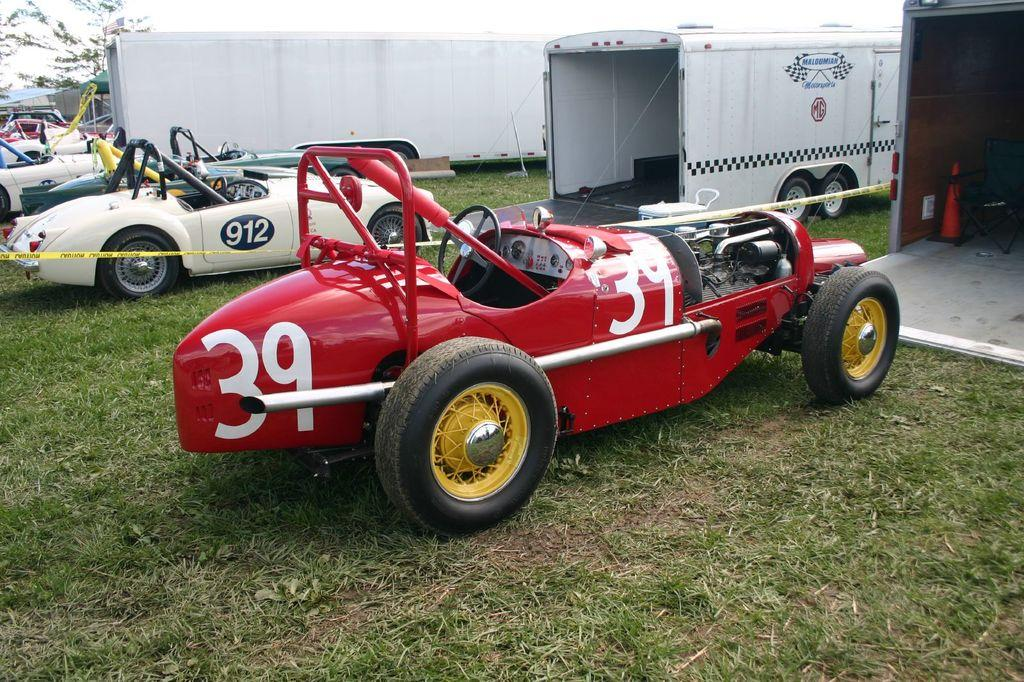What type of vehicles are on the grass in the image? The facts do not specify the type of vehicles, but there are vehicles on the grass in the image. What type of furniture is in the image? There is a chair in the image. What type of barrier is in the image? There is a cone barricade in the image. What type of shelter is in the image? There is a canopy tent in the image. What type of natural scenery is visible in the background of the image? There are trees in the background of the image. What part of the natural environment is visible in the background of the image? The sky is visible in the background of the image. Where is the quicksand located in the image? There is no quicksand present in the image. What type of rule is being enforced by the cone barricade in the image? The cone barricade is not enforcing any rule in the image; it is simply a barrier. 